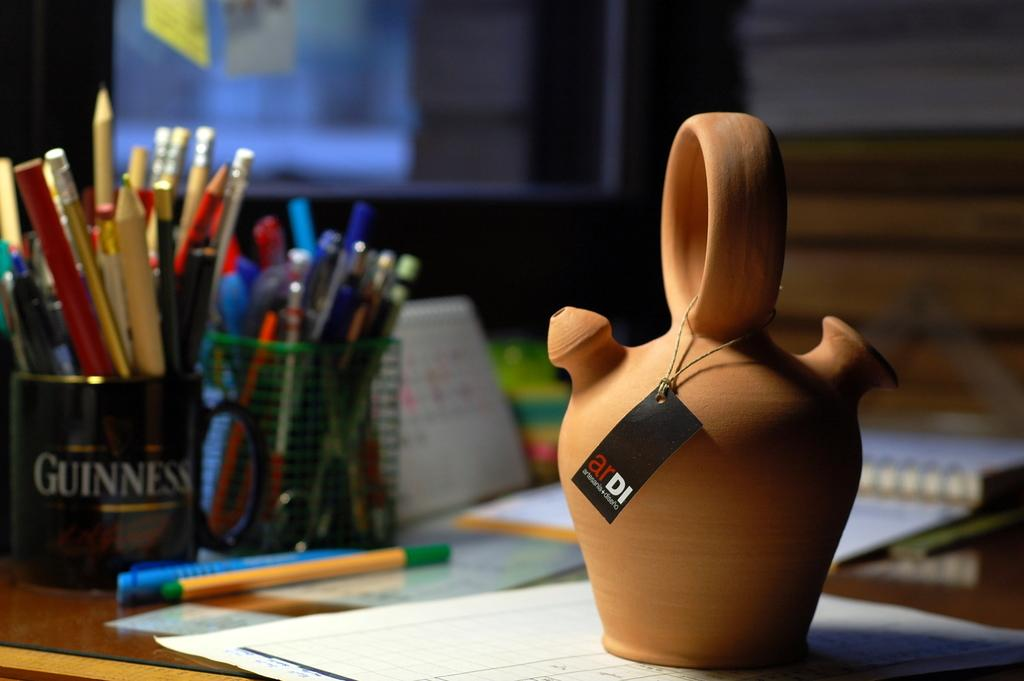<image>
Write a terse but informative summary of the picture. Guinness cup with pencils and pens on a table with paper 